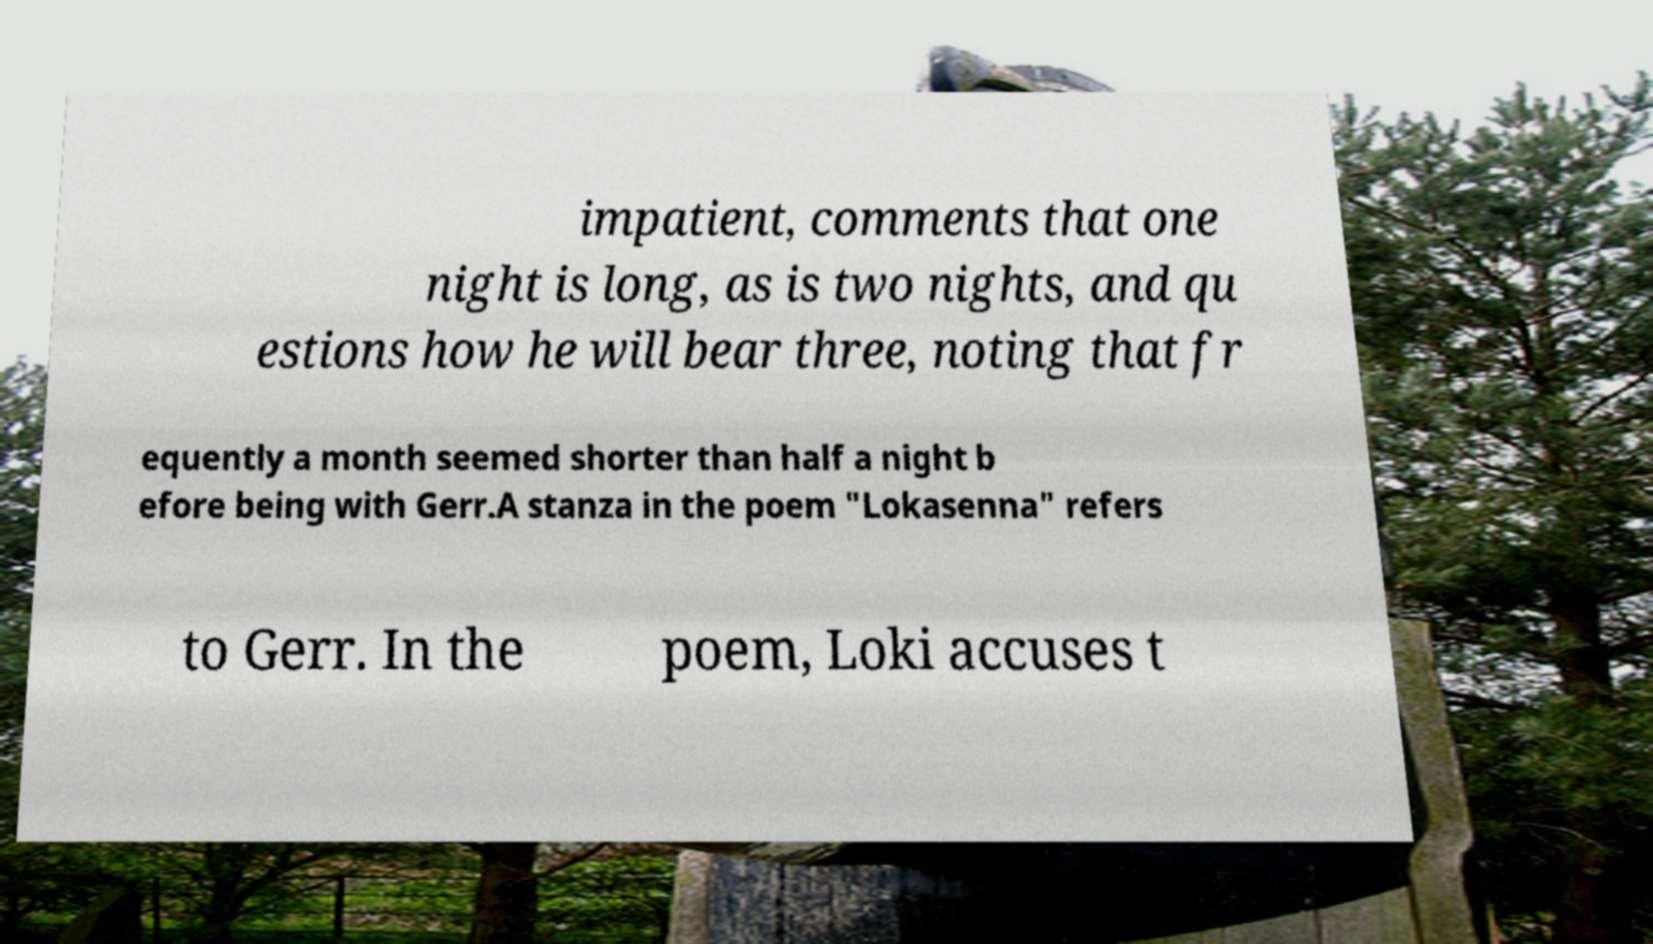Can you accurately transcribe the text from the provided image for me? impatient, comments that one night is long, as is two nights, and qu estions how he will bear three, noting that fr equently a month seemed shorter than half a night b efore being with Gerr.A stanza in the poem "Lokasenna" refers to Gerr. In the poem, Loki accuses t 